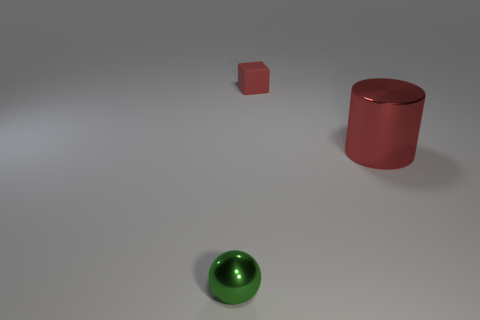Are there any other things that are the same material as the red block?
Give a very brief answer. No. There is a cylinder that is made of the same material as the green ball; what size is it?
Make the answer very short. Large. What is the tiny green ball made of?
Offer a very short reply. Metal. What number of spheres have the same size as the block?
Offer a very short reply. 1. What is the shape of the tiny rubber object that is the same color as the cylinder?
Give a very brief answer. Cube. Is there another tiny green metallic thing of the same shape as the tiny green shiny thing?
Ensure brevity in your answer.  No. What is the color of the metal thing that is the same size as the red matte thing?
Keep it short and to the point. Green. There is a shiny thing that is behind the object in front of the big cylinder; what color is it?
Your answer should be very brief. Red. There is a small object that is in front of the tiny rubber thing; does it have the same color as the large metal object?
Offer a very short reply. No. There is a metal thing behind the thing that is to the left of the red thing that is behind the cylinder; what is its shape?
Give a very brief answer. Cylinder. 